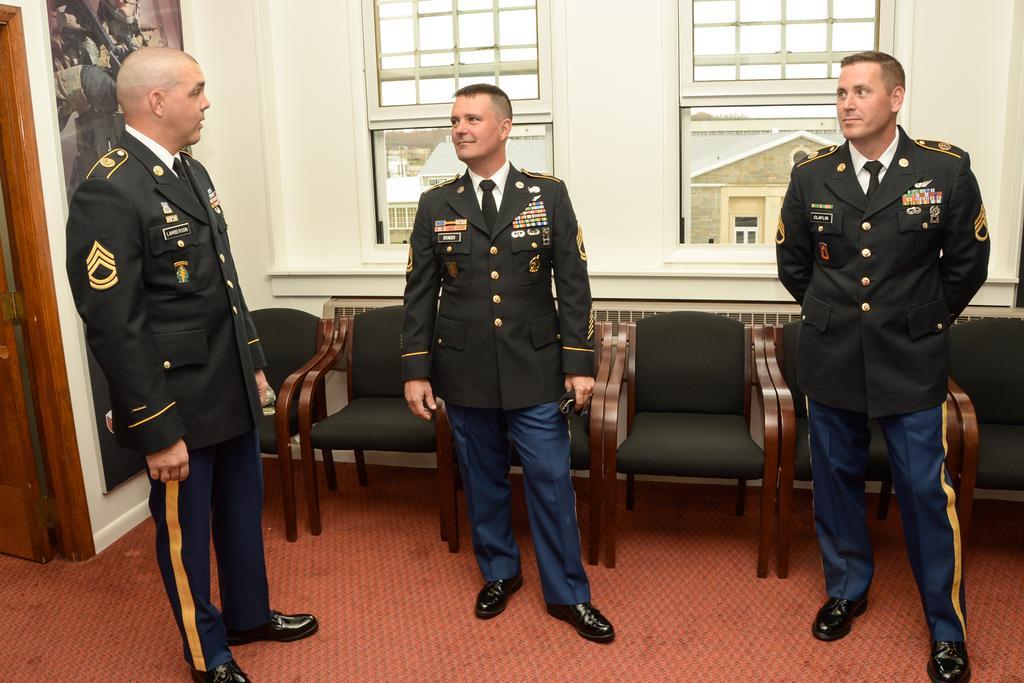Please provide a concise description of this image. In this image there are three military officers standing on the floor one beside the other. In the background there are five chairs. At the top there are two windows. On the left side there is a door. To the wall there is a poster. Through the window we can see the building. On the floor there is a red colour mat. 